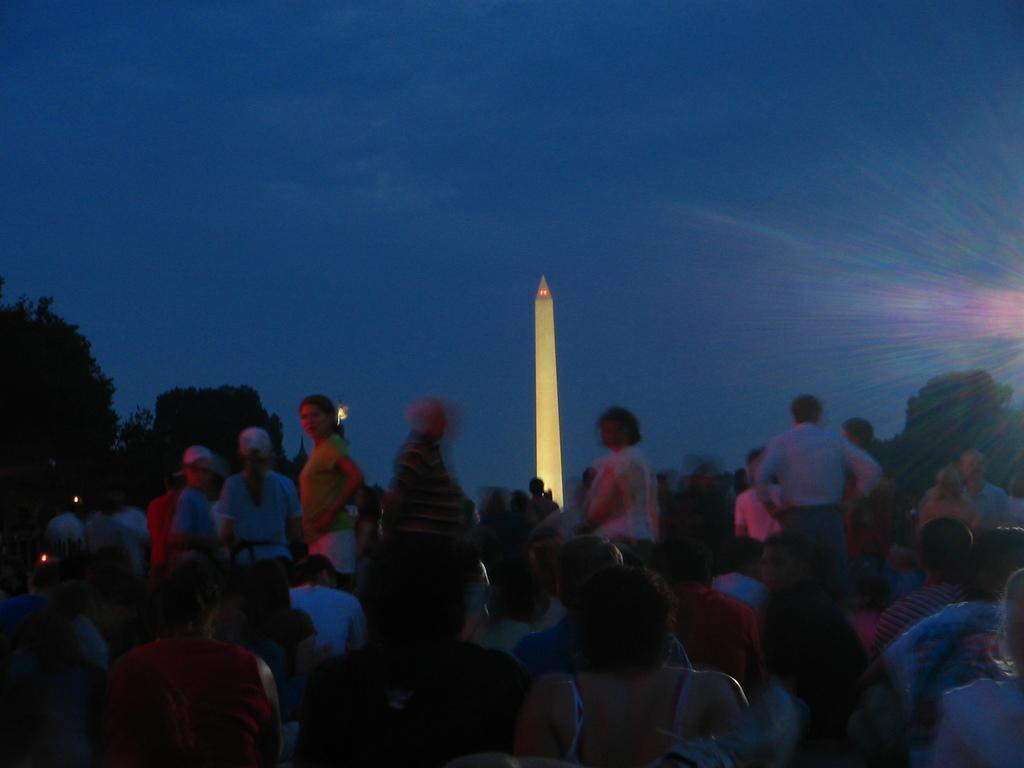Could you give a brief overview of what you see in this image? In this picture I see few people standing in the front and few people might seated on the back and I see trees on the left and right side of the picture and it might be a tower with lighting and I see a blue sky. 